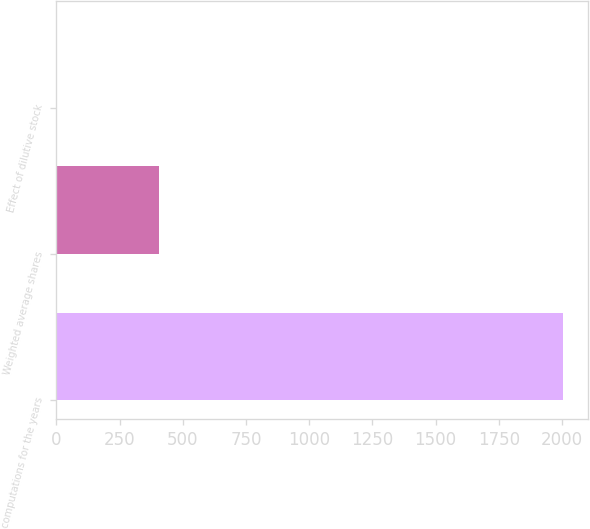Convert chart to OTSL. <chart><loc_0><loc_0><loc_500><loc_500><bar_chart><fcel>computations for the years<fcel>Weighted average shares<fcel>Effect of dilutive stock<nl><fcel>2003<fcel>407.65<fcel>3.5<nl></chart> 